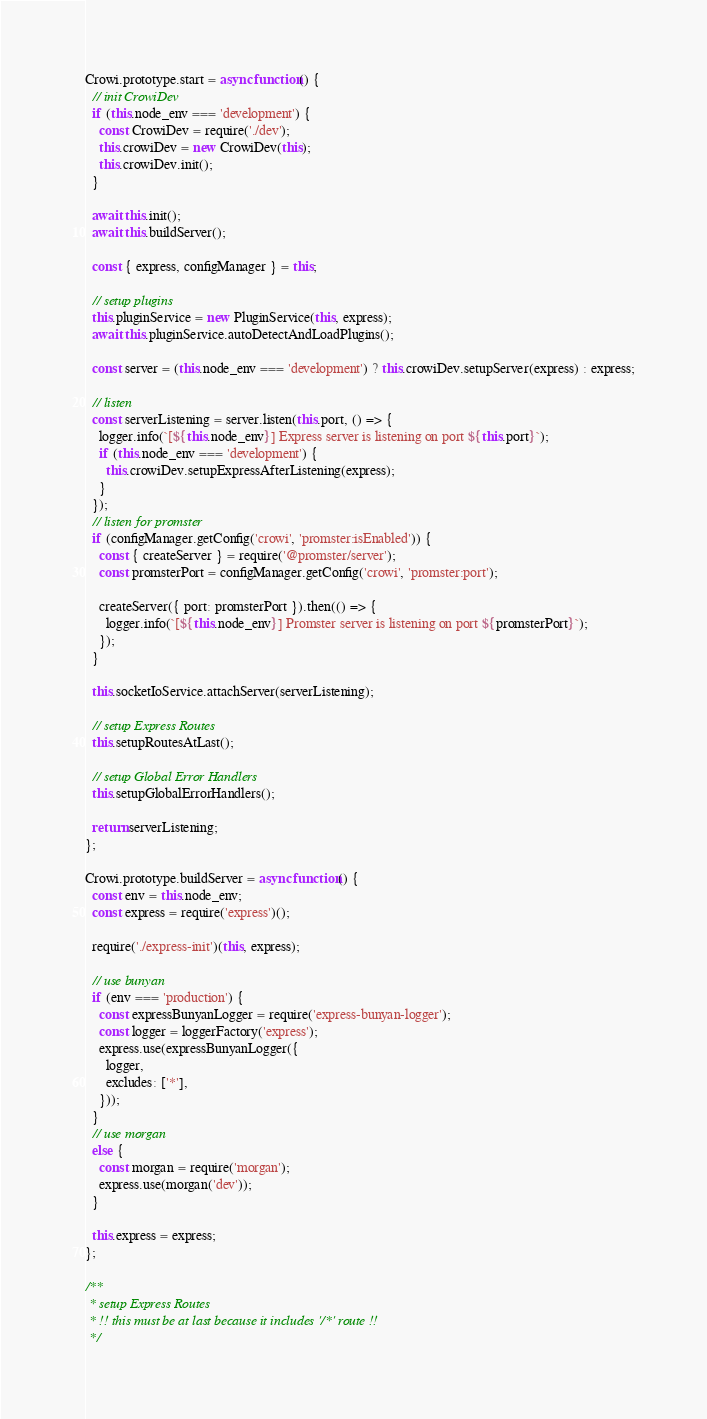<code> <loc_0><loc_0><loc_500><loc_500><_JavaScript_>
Crowi.prototype.start = async function() {
  // init CrowiDev
  if (this.node_env === 'development') {
    const CrowiDev = require('./dev');
    this.crowiDev = new CrowiDev(this);
    this.crowiDev.init();
  }

  await this.init();
  await this.buildServer();

  const { express, configManager } = this;

  // setup plugins
  this.pluginService = new PluginService(this, express);
  await this.pluginService.autoDetectAndLoadPlugins();

  const server = (this.node_env === 'development') ? this.crowiDev.setupServer(express) : express;

  // listen
  const serverListening = server.listen(this.port, () => {
    logger.info(`[${this.node_env}] Express server is listening on port ${this.port}`);
    if (this.node_env === 'development') {
      this.crowiDev.setupExpressAfterListening(express);
    }
  });
  // listen for promster
  if (configManager.getConfig('crowi', 'promster:isEnabled')) {
    const { createServer } = require('@promster/server');
    const promsterPort = configManager.getConfig('crowi', 'promster:port');

    createServer({ port: promsterPort }).then(() => {
      logger.info(`[${this.node_env}] Promster server is listening on port ${promsterPort}`);
    });
  }

  this.socketIoService.attachServer(serverListening);

  // setup Express Routes
  this.setupRoutesAtLast();

  // setup Global Error Handlers
  this.setupGlobalErrorHandlers();

  return serverListening;
};

Crowi.prototype.buildServer = async function() {
  const env = this.node_env;
  const express = require('express')();

  require('./express-init')(this, express);

  // use bunyan
  if (env === 'production') {
    const expressBunyanLogger = require('express-bunyan-logger');
    const logger = loggerFactory('express');
    express.use(expressBunyanLogger({
      logger,
      excludes: ['*'],
    }));
  }
  // use morgan
  else {
    const morgan = require('morgan');
    express.use(morgan('dev'));
  }

  this.express = express;
};

/**
 * setup Express Routes
 * !! this must be at last because it includes '/*' route !!
 */</code> 